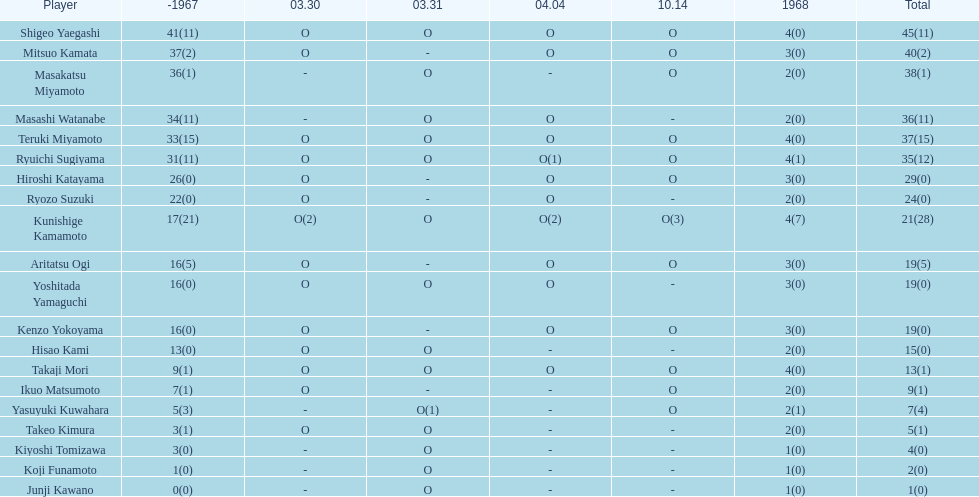Which player had a higher score, takaji mori or junji kawano? Takaji Mori. 